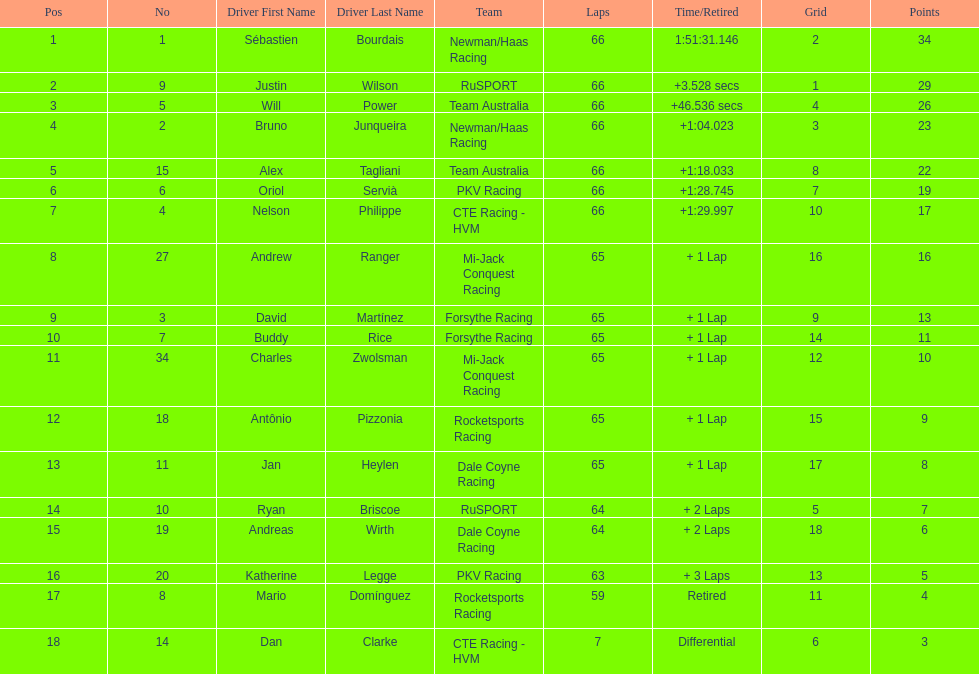At the 2006 gran premio telmex, did oriol servia or katherine legge complete more laps? Oriol Servià. 